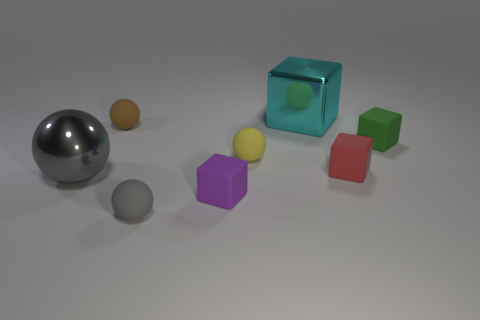Subtract all tiny rubber cubes. How many cubes are left? 1 Subtract all red cubes. How many cubes are left? 3 Add 2 large red shiny balls. How many large red shiny balls exist? 2 Add 2 small blocks. How many objects exist? 10 Subtract 0 yellow blocks. How many objects are left? 8 Subtract 3 balls. How many balls are left? 1 Subtract all purple cubes. Subtract all yellow cylinders. How many cubes are left? 3 Subtract all gray balls. How many brown cubes are left? 0 Subtract all gray metal spheres. Subtract all big objects. How many objects are left? 5 Add 6 tiny gray objects. How many tiny gray objects are left? 7 